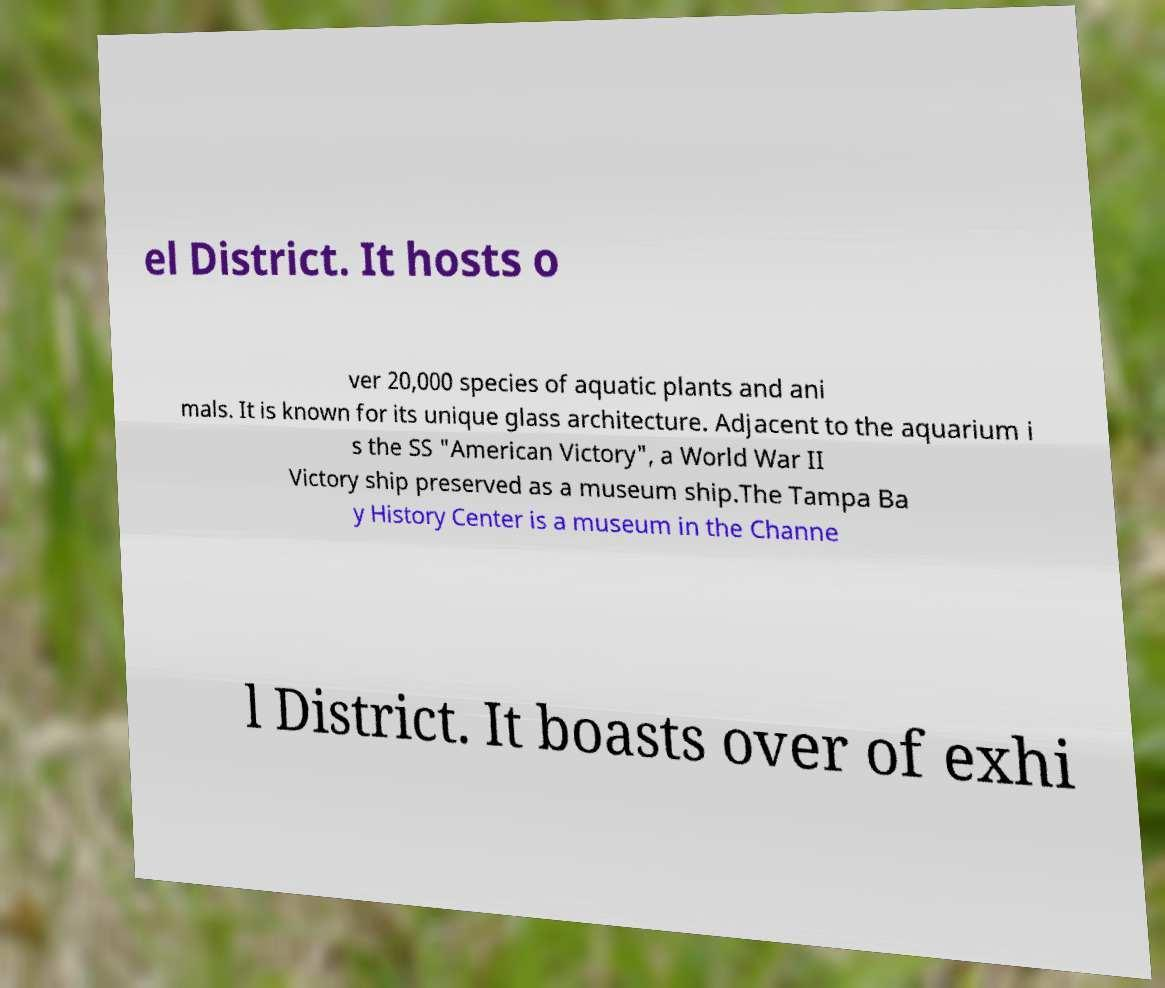Could you extract and type out the text from this image? el District. It hosts o ver 20,000 species of aquatic plants and ani mals. It is known for its unique glass architecture. Adjacent to the aquarium i s the SS "American Victory", a World War II Victory ship preserved as a museum ship.The Tampa Ba y History Center is a museum in the Channe l District. It boasts over of exhi 